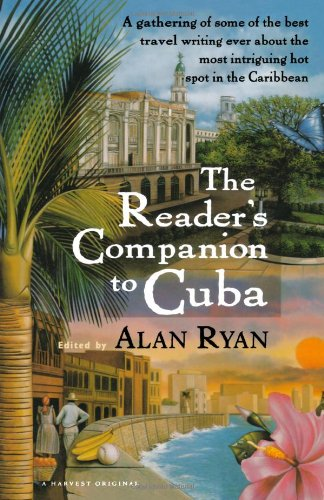How could this book be valuable to someone planning to visit Cuba? The book could serve as an inspirational guide, offering insights into Cuba's culture and must-see locations, as well as practical travel tips from experienced writers. 